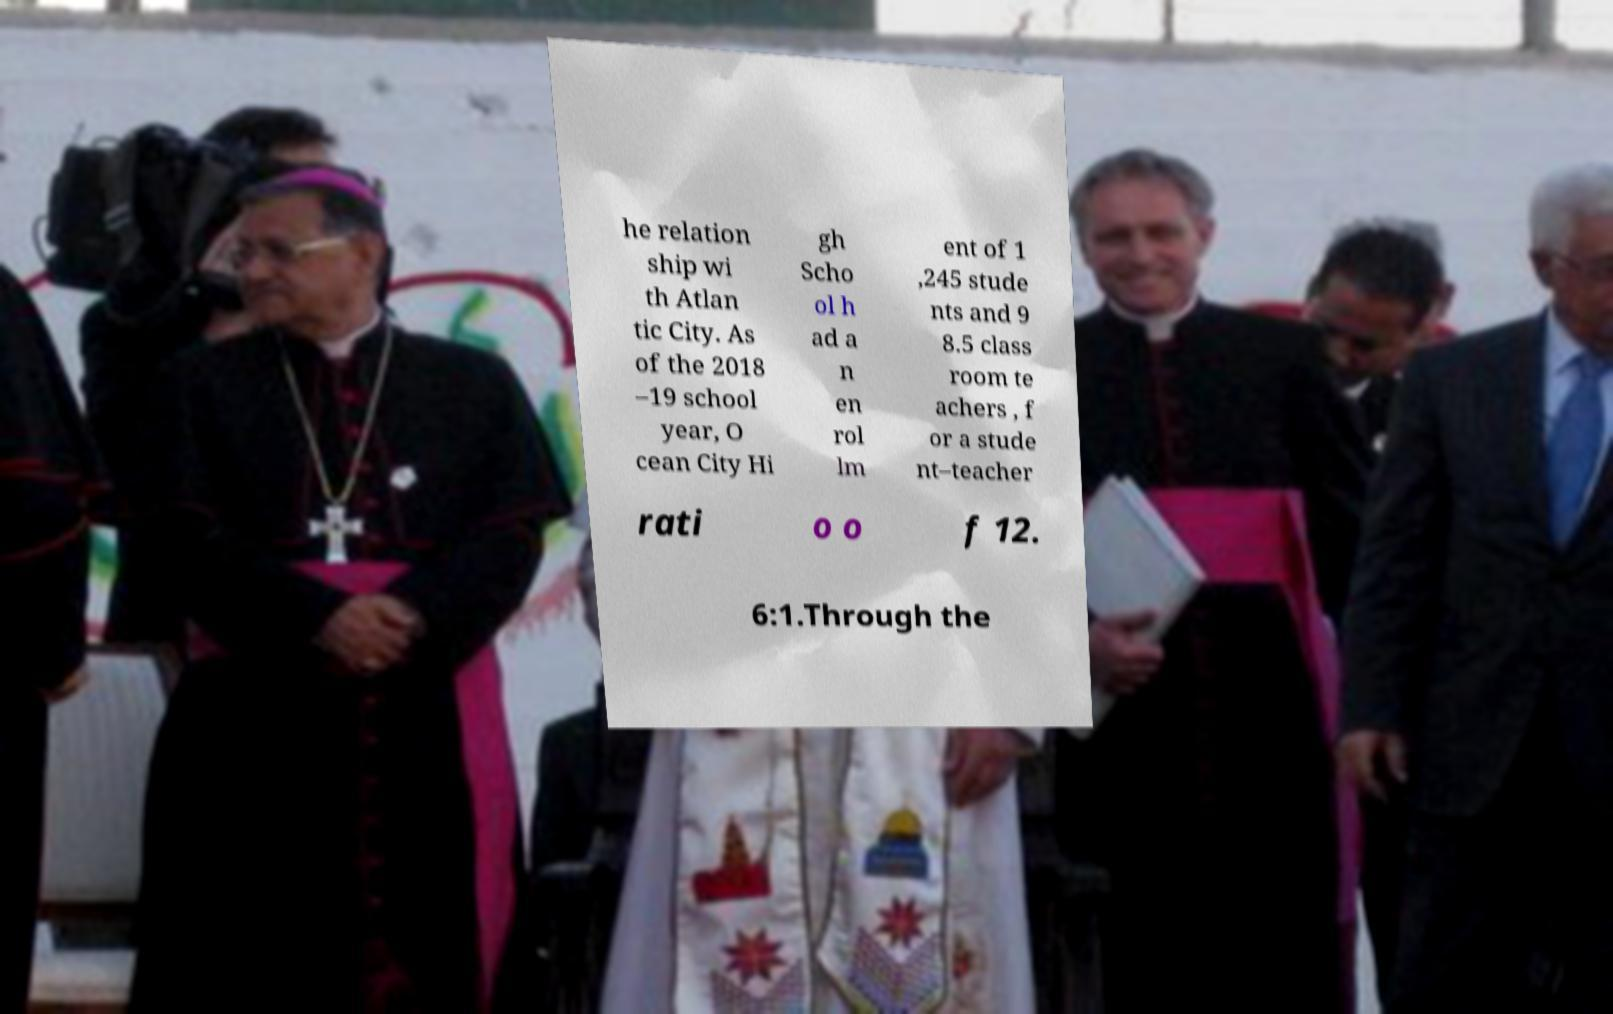Please read and relay the text visible in this image. What does it say? he relation ship wi th Atlan tic City. As of the 2018 –19 school year, O cean City Hi gh Scho ol h ad a n en rol lm ent of 1 ,245 stude nts and 9 8.5 class room te achers , f or a stude nt–teacher rati o o f 12. 6:1.Through the 